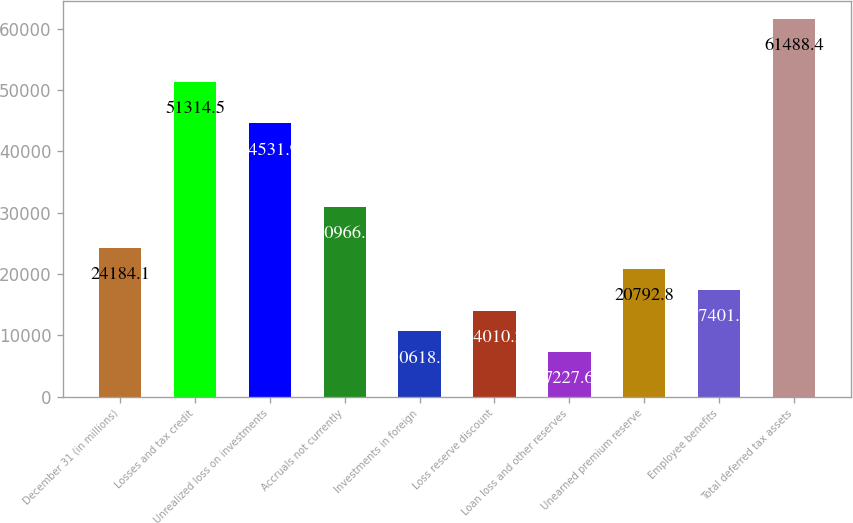<chart> <loc_0><loc_0><loc_500><loc_500><bar_chart><fcel>December 31 (in millions)<fcel>Losses and tax credit<fcel>Unrealized loss on investments<fcel>Accruals not currently<fcel>Investments in foreign<fcel>Loss reserve discount<fcel>Loan loss and other reserves<fcel>Unearned premium reserve<fcel>Employee benefits<fcel>Total deferred tax assets<nl><fcel>24184.1<fcel>51314.5<fcel>44531.9<fcel>30966.7<fcel>10618.9<fcel>14010.2<fcel>7227.6<fcel>20792.8<fcel>17401.5<fcel>61488.4<nl></chart> 